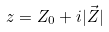<formula> <loc_0><loc_0><loc_500><loc_500>z = Z _ { 0 } + i | \vec { Z } |</formula> 